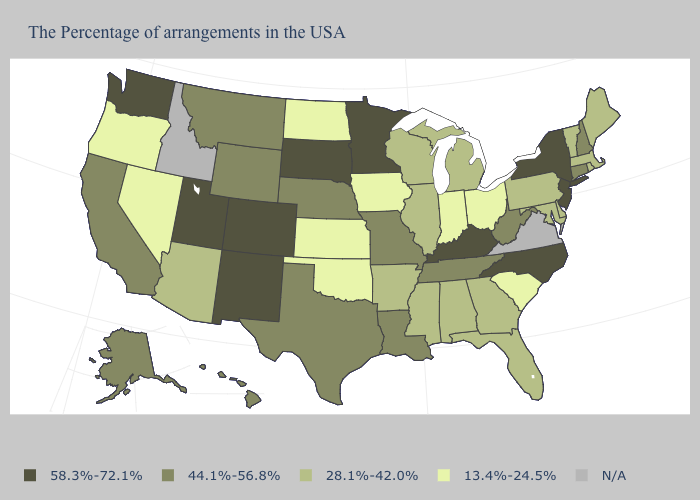What is the lowest value in states that border New Hampshire?
Keep it brief. 28.1%-42.0%. Name the states that have a value in the range 58.3%-72.1%?
Keep it brief. New York, New Jersey, North Carolina, Kentucky, Minnesota, South Dakota, Colorado, New Mexico, Utah, Washington. What is the value of Louisiana?
Answer briefly. 44.1%-56.8%. What is the value of South Carolina?
Answer briefly. 13.4%-24.5%. Name the states that have a value in the range 44.1%-56.8%?
Write a very short answer. New Hampshire, Connecticut, West Virginia, Tennessee, Louisiana, Missouri, Nebraska, Texas, Wyoming, Montana, California, Alaska, Hawaii. What is the value of Oklahoma?
Write a very short answer. 13.4%-24.5%. What is the highest value in the USA?
Keep it brief. 58.3%-72.1%. What is the value of South Dakota?
Concise answer only. 58.3%-72.1%. Does Florida have the lowest value in the USA?
Keep it brief. No. Name the states that have a value in the range N/A?
Be succinct. Virginia, Idaho. What is the highest value in the West ?
Give a very brief answer. 58.3%-72.1%. Does Colorado have the highest value in the USA?
Keep it brief. Yes. Name the states that have a value in the range 44.1%-56.8%?
Give a very brief answer. New Hampshire, Connecticut, West Virginia, Tennessee, Louisiana, Missouri, Nebraska, Texas, Wyoming, Montana, California, Alaska, Hawaii. Is the legend a continuous bar?
Concise answer only. No. 